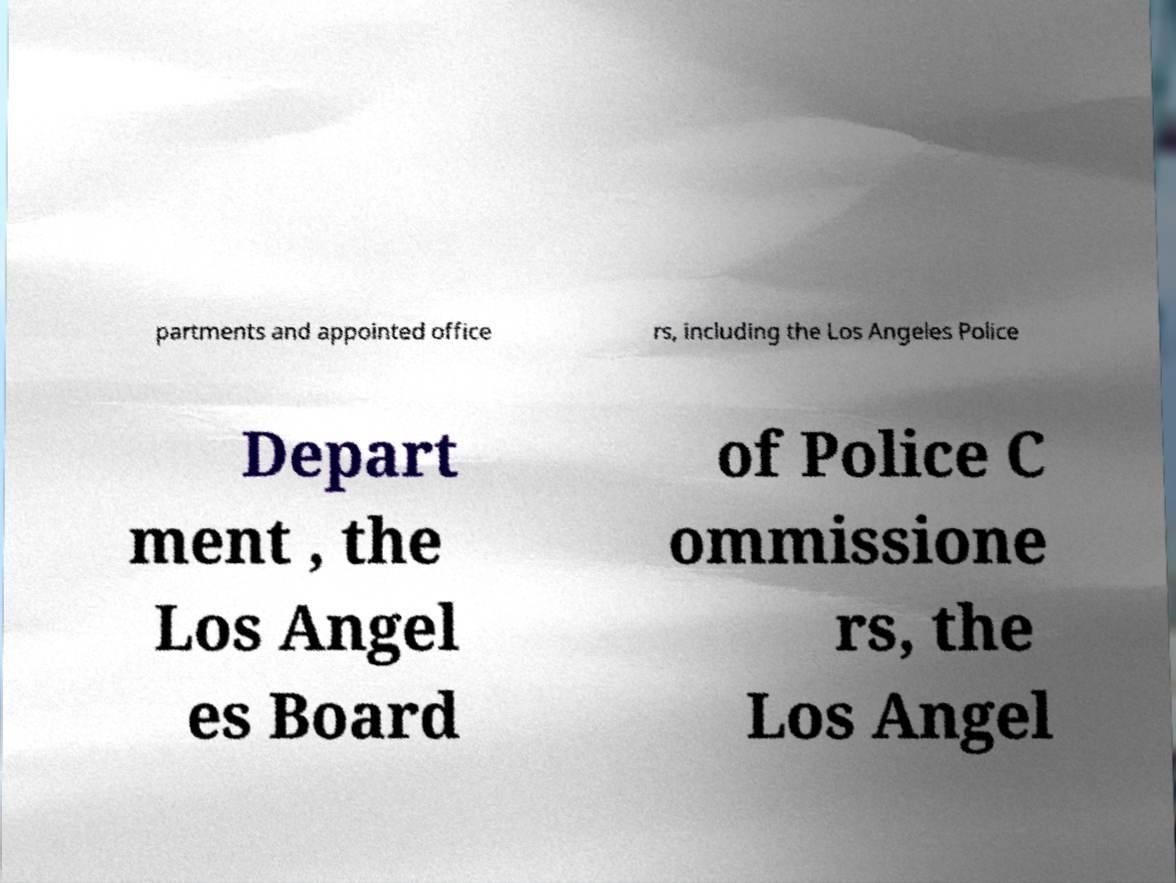Can you accurately transcribe the text from the provided image for me? partments and appointed office rs, including the Los Angeles Police Depart ment , the Los Angel es Board of Police C ommissione rs, the Los Angel 